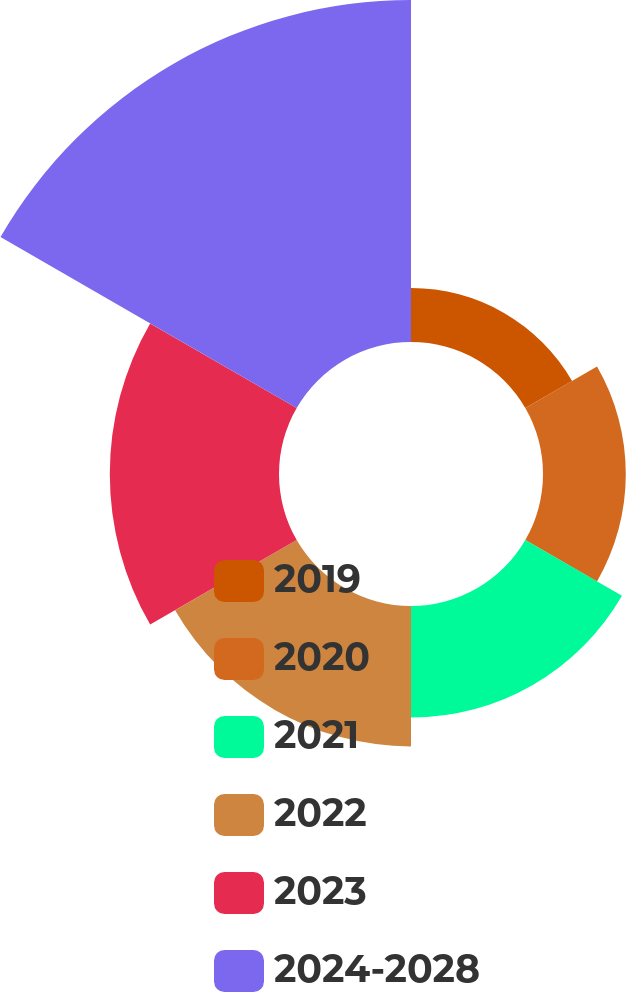<chart> <loc_0><loc_0><loc_500><loc_500><pie_chart><fcel>2019<fcel>2020<fcel>2021<fcel>2022<fcel>2023<fcel>2024-2028<nl><fcel>6.0%<fcel>9.2%<fcel>12.4%<fcel>15.6%<fcel>18.8%<fcel>38.0%<nl></chart> 